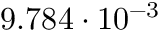Convert formula to latex. <formula><loc_0><loc_0><loc_500><loc_500>9 . 7 8 4 \cdot 1 0 ^ { - 3 }</formula> 